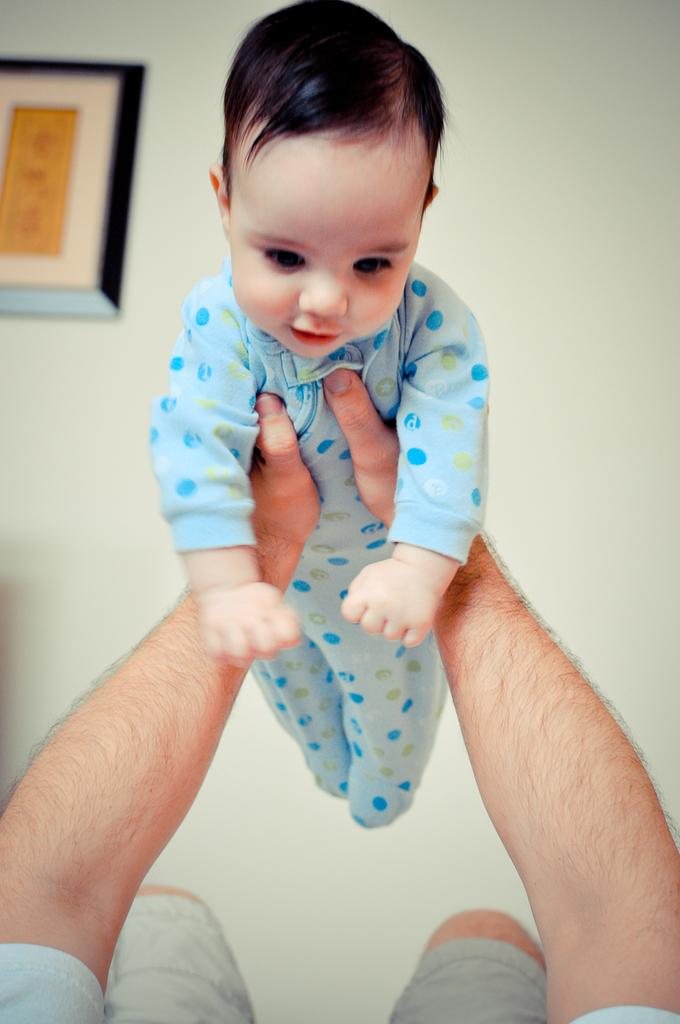Who is the main subject in the image? There is a person in the image. What is the person doing in the image? The person is lifting a baby. What can be seen in the background of the image? There is a photo frame on the wall in the background of the image. What type of oatmeal is being served in the image? There is no oatmeal present in the image. How can someone join the ongoing activity in the image? There is no ongoing activity in the image that someone can join. 